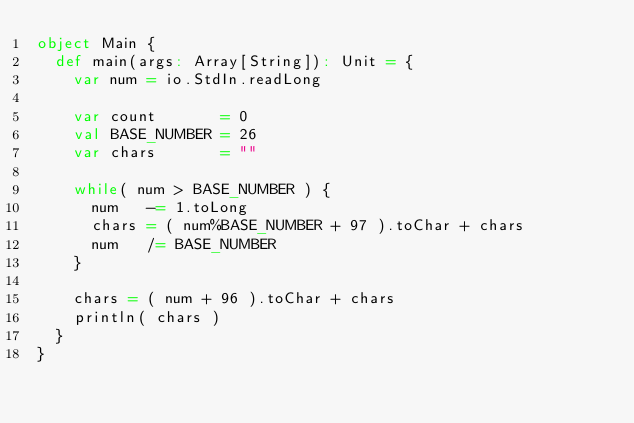<code> <loc_0><loc_0><loc_500><loc_500><_Scala_>object Main {
  def main(args: Array[String]): Unit = {
    var num = io.StdIn.readLong

    var count       = 0
    val BASE_NUMBER = 26
    var chars       = ""

    while( num > BASE_NUMBER ) {
      num   -= 1.toLong
      chars = ( num%BASE_NUMBER + 97 ).toChar + chars
      num   /= BASE_NUMBER
    }
    
    chars = ( num + 96 ).toChar + chars
    println( chars )
  }
}</code> 